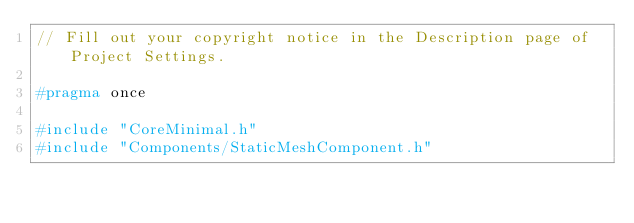<code> <loc_0><loc_0><loc_500><loc_500><_C_>// Fill out your copyright notice in the Description page of Project Settings.

#pragma once

#include "CoreMinimal.h"
#include "Components/StaticMeshComponent.h"</code> 